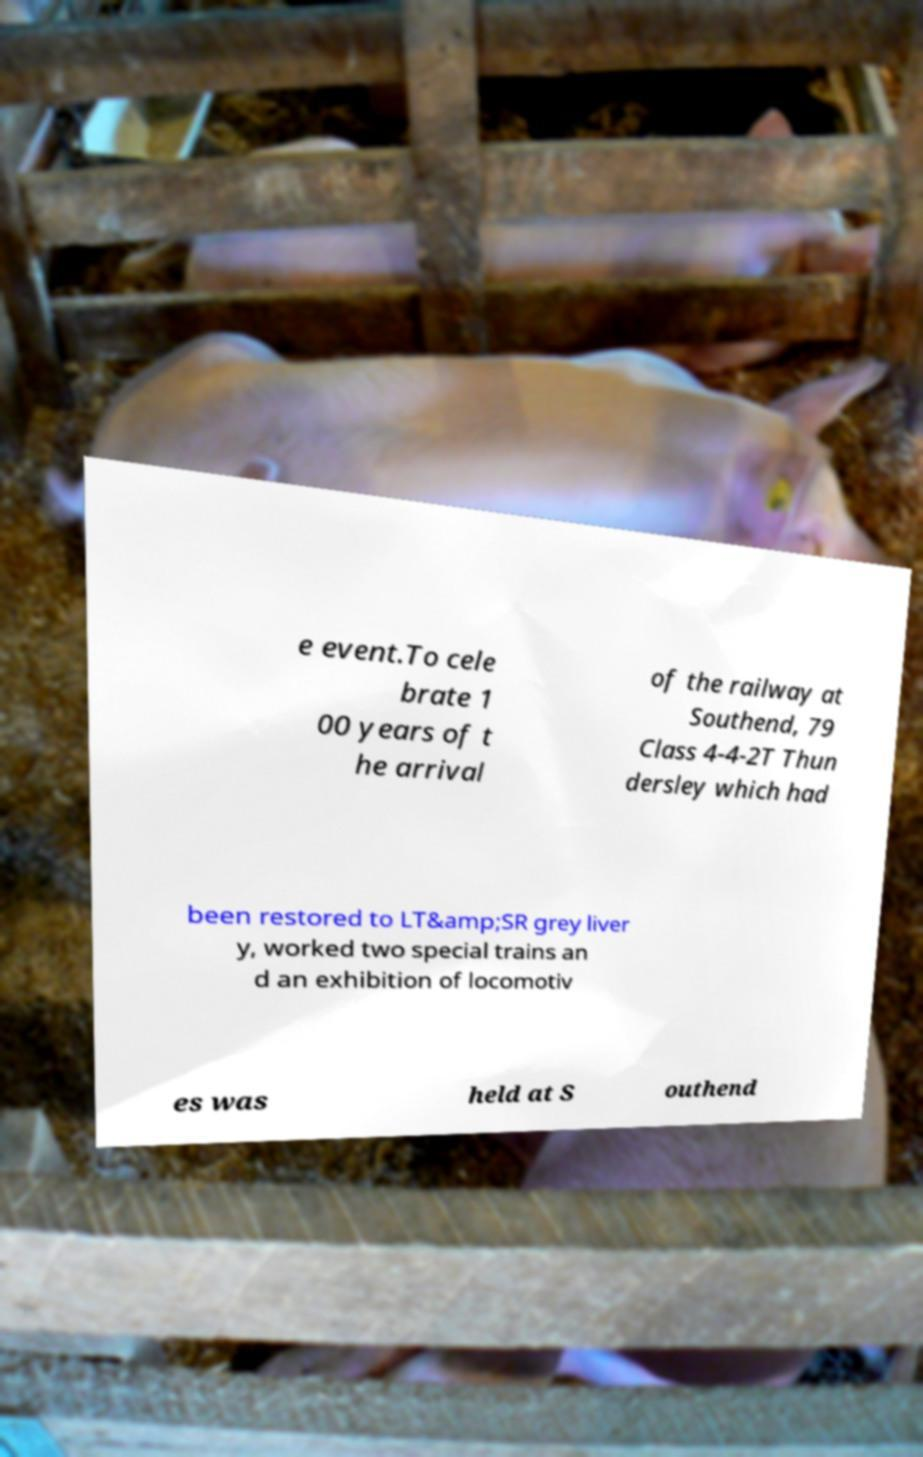Can you accurately transcribe the text from the provided image for me? e event.To cele brate 1 00 years of t he arrival of the railway at Southend, 79 Class 4-4-2T Thun dersley which had been restored to LT&amp;SR grey liver y, worked two special trains an d an exhibition of locomotiv es was held at S outhend 